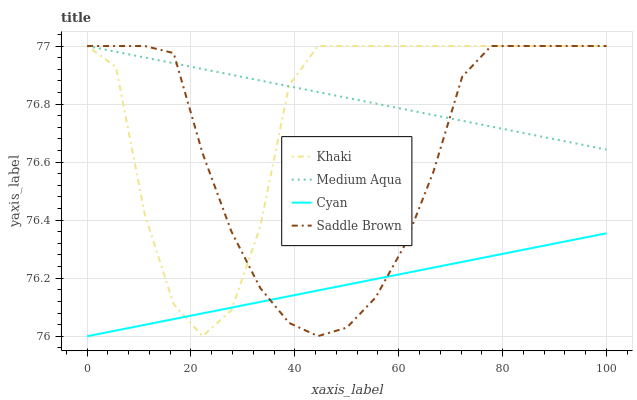Does Cyan have the minimum area under the curve?
Answer yes or no. Yes. Does Medium Aqua have the maximum area under the curve?
Answer yes or no. Yes. Does Khaki have the minimum area under the curve?
Answer yes or no. No. Does Khaki have the maximum area under the curve?
Answer yes or no. No. Is Cyan the smoothest?
Answer yes or no. Yes. Is Khaki the roughest?
Answer yes or no. Yes. Is Medium Aqua the smoothest?
Answer yes or no. No. Is Medium Aqua the roughest?
Answer yes or no. No. Does Cyan have the lowest value?
Answer yes or no. Yes. Does Khaki have the lowest value?
Answer yes or no. No. Does Saddle Brown have the highest value?
Answer yes or no. Yes. Is Cyan less than Medium Aqua?
Answer yes or no. Yes. Is Medium Aqua greater than Cyan?
Answer yes or no. Yes. Does Saddle Brown intersect Khaki?
Answer yes or no. Yes. Is Saddle Brown less than Khaki?
Answer yes or no. No. Is Saddle Brown greater than Khaki?
Answer yes or no. No. Does Cyan intersect Medium Aqua?
Answer yes or no. No. 